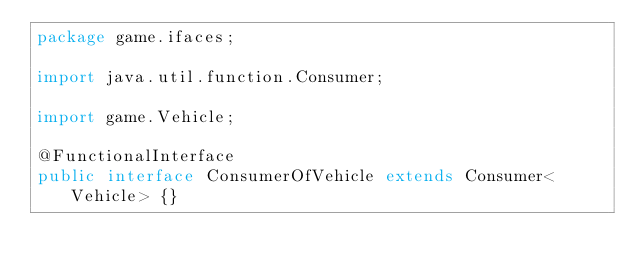<code> <loc_0><loc_0><loc_500><loc_500><_Java_>package game.ifaces;

import java.util.function.Consumer;

import game.Vehicle;

@FunctionalInterface
public interface ConsumerOfVehicle extends Consumer<Vehicle> {}
</code> 